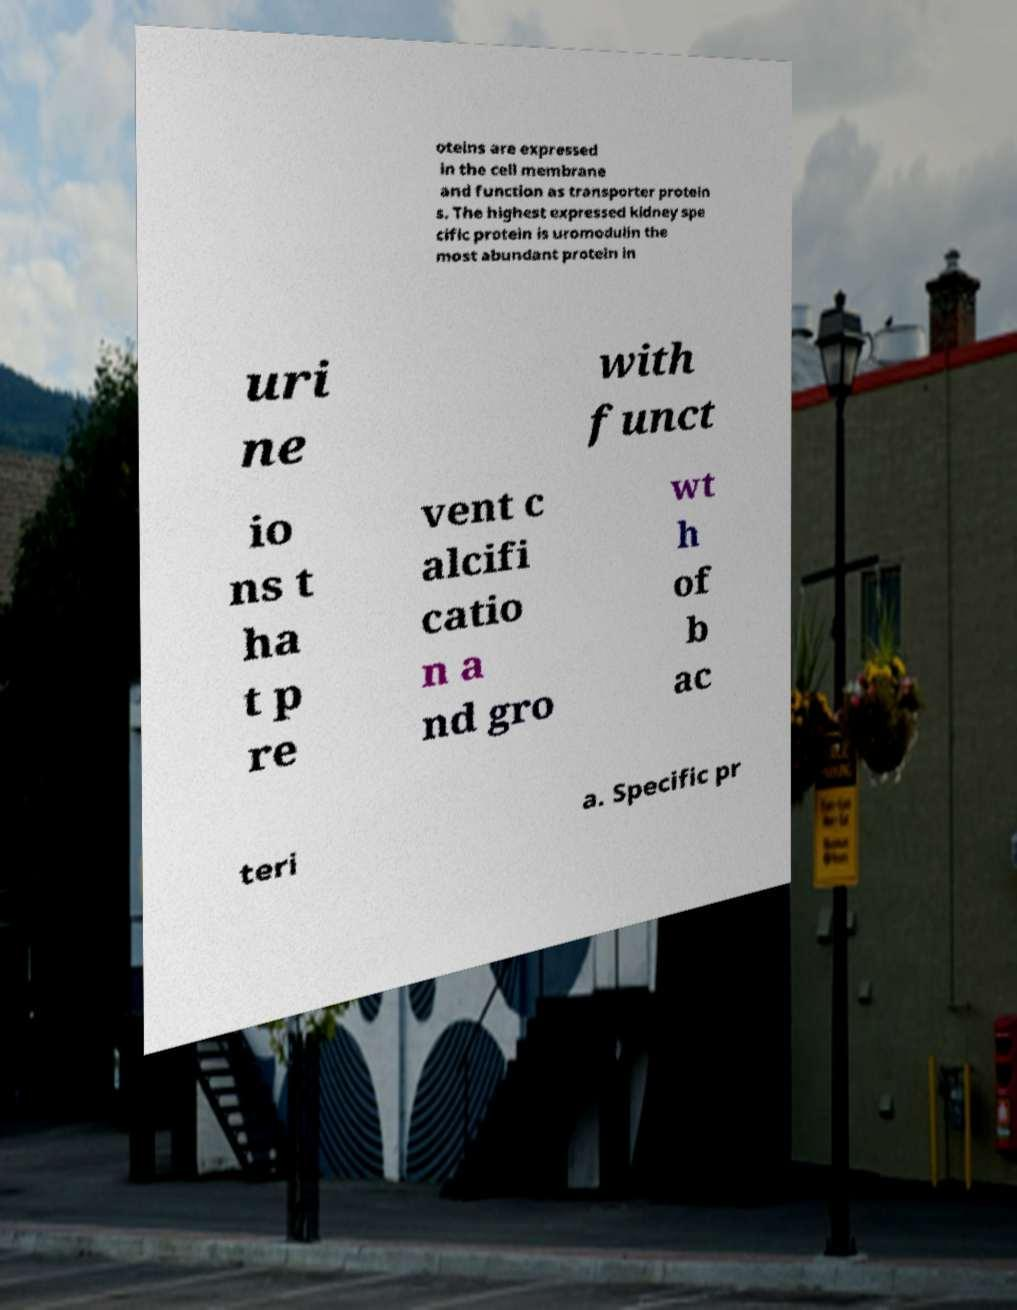Please read and relay the text visible in this image. What does it say? oteins are expressed in the cell membrane and function as transporter protein s. The highest expressed kidney spe cific protein is uromodulin the most abundant protein in uri ne with funct io ns t ha t p re vent c alcifi catio n a nd gro wt h of b ac teri a. Specific pr 